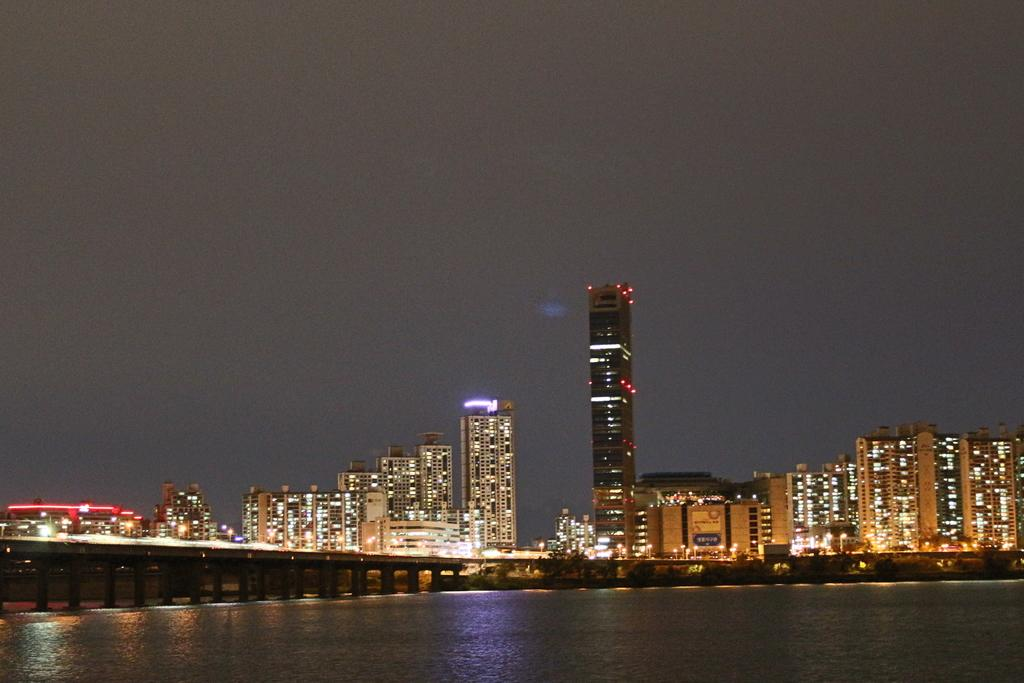What type of structures can be seen in the background of the image? There are buildings with lights in the background of the image. What is the main feature in the middle of the image? There is a bridge in the image. What natural element is visible at the bottom of the image? There is water visible at the bottom of the image. What part of the natural environment is visible at the top of the image? There is sky visible at the top of the image. Can you tell me how many volcanoes are present in the image? There are no volcanoes present in the image. What type of act is being performed on the bridge in the image? There is no act being performed on the bridge in the image; it is a static structure. 